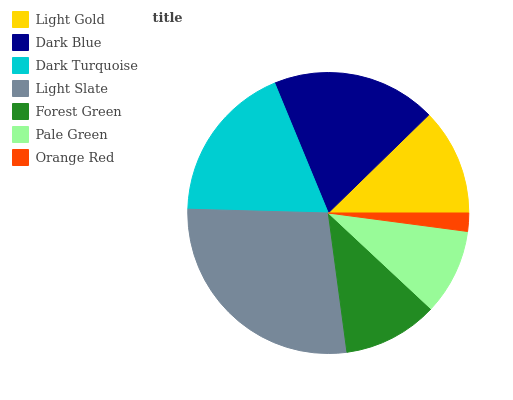Is Orange Red the minimum?
Answer yes or no. Yes. Is Light Slate the maximum?
Answer yes or no. Yes. Is Dark Blue the minimum?
Answer yes or no. No. Is Dark Blue the maximum?
Answer yes or no. No. Is Dark Blue greater than Light Gold?
Answer yes or no. Yes. Is Light Gold less than Dark Blue?
Answer yes or no. Yes. Is Light Gold greater than Dark Blue?
Answer yes or no. No. Is Dark Blue less than Light Gold?
Answer yes or no. No. Is Light Gold the high median?
Answer yes or no. Yes. Is Light Gold the low median?
Answer yes or no. Yes. Is Dark Turquoise the high median?
Answer yes or no. No. Is Dark Blue the low median?
Answer yes or no. No. 